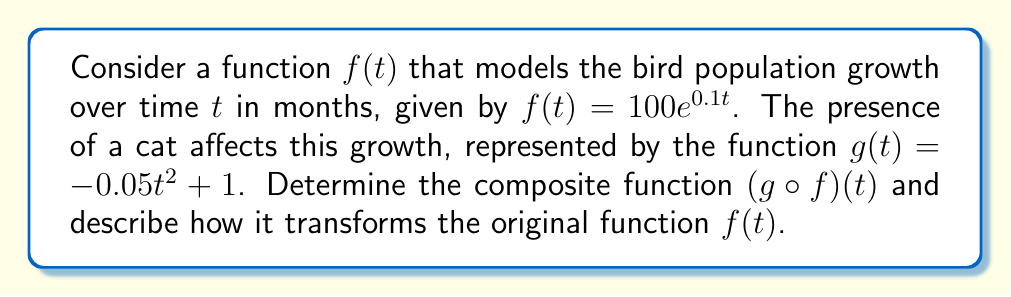Can you solve this math problem? To find the composite function $(g \circ f)(t)$, we need to substitute $f(t)$ into $g(t)$:

1) Start with $g(t) = -0.05t^2 + 1$
2) Replace $t$ with $f(t) = 100e^{0.1t}$

$$(g \circ f)(t) = -0.05(100e^{0.1t})^2 + 1$$

3) Simplify:
$$(g \circ f)(t) = -0.05(10000e^{0.2t}) + 1$$
$$(g \circ f)(t) = -500e^{0.2t} + 1$$

4) Analyze the transformation:
   - The negative coefficient $-500$ reflects the function vertically.
   - The exponential term $e^{0.2t}$ causes the function to grow faster than the original $f(t)$.
   - The $+1$ at the end translates the function up by 1 unit.

5) As $t$ increases, $(g \circ f)(t)$ will decrease rapidly due to the negative coefficient, approaching but never crossing $y=1$ (horizontal asymptote).

This composite function represents how the cat's presence (modeled by $g(t)$) affects the bird population growth (modeled by $f(t)$), resulting in a decreasing population over time.
Answer: $(g \circ f)(t) = -500e^{0.2t} + 1$ 